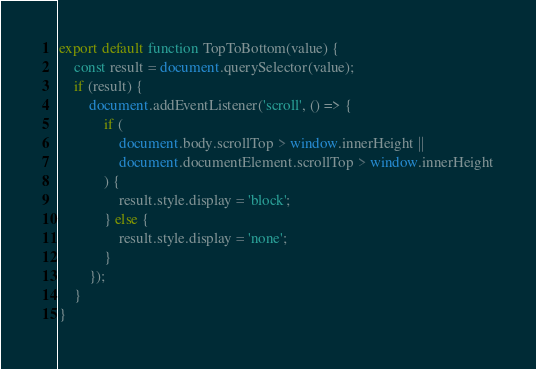<code> <loc_0><loc_0><loc_500><loc_500><_JavaScript_>export default function TopToBottom(value) {
    const result = document.querySelector(value);
    if (result) {
        document.addEventListener('scroll', () => {
            if (
                document.body.scrollTop > window.innerHeight ||
                document.documentElement.scrollTop > window.innerHeight
            ) {
                result.style.display = 'block';
            } else {
                result.style.display = 'none';
            }
        });
    }
}
</code> 